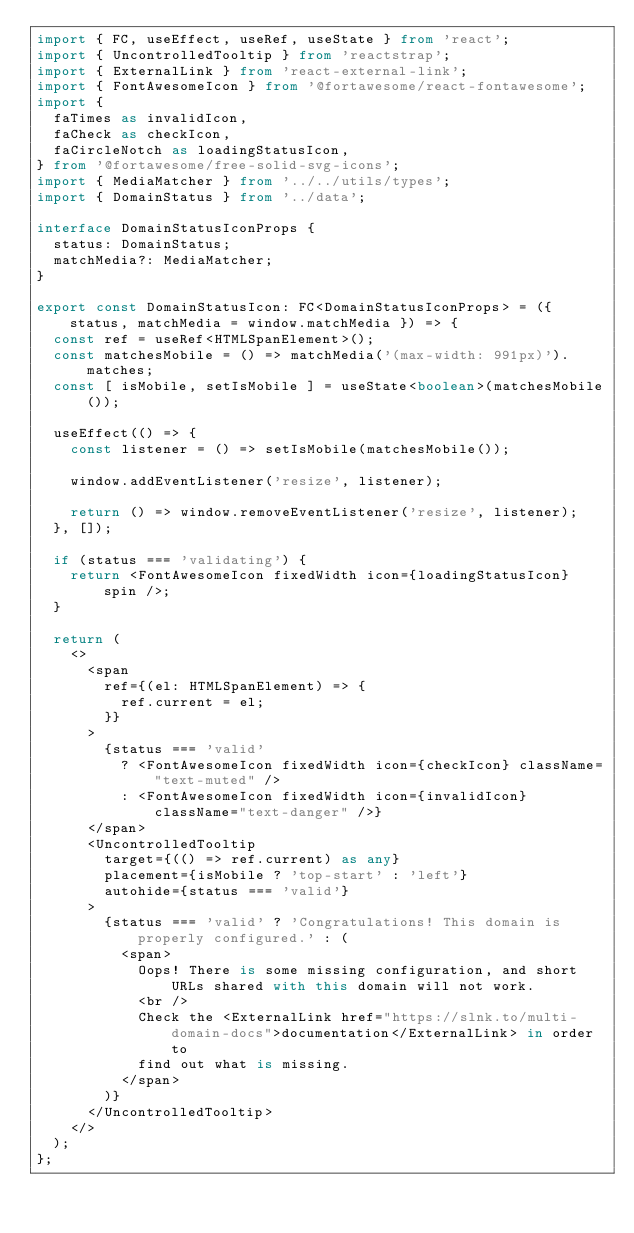<code> <loc_0><loc_0><loc_500><loc_500><_TypeScript_>import { FC, useEffect, useRef, useState } from 'react';
import { UncontrolledTooltip } from 'reactstrap';
import { ExternalLink } from 'react-external-link';
import { FontAwesomeIcon } from '@fortawesome/react-fontawesome';
import {
  faTimes as invalidIcon,
  faCheck as checkIcon,
  faCircleNotch as loadingStatusIcon,
} from '@fortawesome/free-solid-svg-icons';
import { MediaMatcher } from '../../utils/types';
import { DomainStatus } from '../data';

interface DomainStatusIconProps {
  status: DomainStatus;
  matchMedia?: MediaMatcher;
}

export const DomainStatusIcon: FC<DomainStatusIconProps> = ({ status, matchMedia = window.matchMedia }) => {
  const ref = useRef<HTMLSpanElement>();
  const matchesMobile = () => matchMedia('(max-width: 991px)').matches;
  const [ isMobile, setIsMobile ] = useState<boolean>(matchesMobile());

  useEffect(() => {
    const listener = () => setIsMobile(matchesMobile());

    window.addEventListener('resize', listener);

    return () => window.removeEventListener('resize', listener);
  }, []);

  if (status === 'validating') {
    return <FontAwesomeIcon fixedWidth icon={loadingStatusIcon} spin />;
  }

  return (
    <>
      <span
        ref={(el: HTMLSpanElement) => {
          ref.current = el;
        }}
      >
        {status === 'valid'
          ? <FontAwesomeIcon fixedWidth icon={checkIcon} className="text-muted" />
          : <FontAwesomeIcon fixedWidth icon={invalidIcon} className="text-danger" />}
      </span>
      <UncontrolledTooltip
        target={(() => ref.current) as any}
        placement={isMobile ? 'top-start' : 'left'}
        autohide={status === 'valid'}
      >
        {status === 'valid' ? 'Congratulations! This domain is properly configured.' : (
          <span>
            Oops! There is some missing configuration, and short URLs shared with this domain will not work.
            <br />
            Check the <ExternalLink href="https://slnk.to/multi-domain-docs">documentation</ExternalLink> in order to
            find out what is missing.
          </span>
        )}
      </UncontrolledTooltip>
    </>
  );
};
</code> 